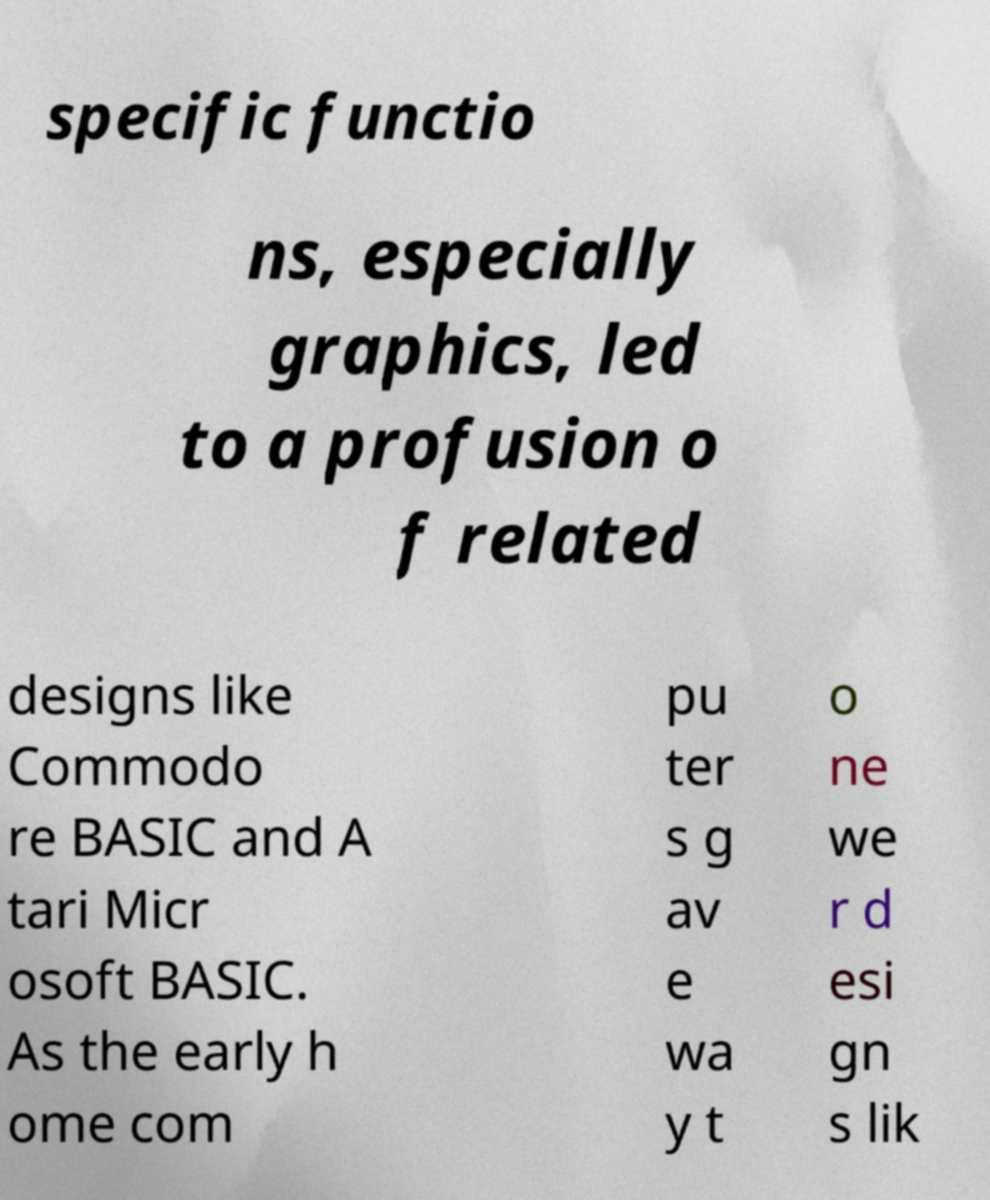Can you accurately transcribe the text from the provided image for me? specific functio ns, especially graphics, led to a profusion o f related designs like Commodo re BASIC and A tari Micr osoft BASIC. As the early h ome com pu ter s g av e wa y t o ne we r d esi gn s lik 